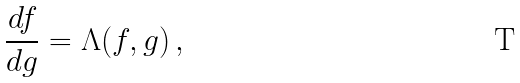<formula> <loc_0><loc_0><loc_500><loc_500>\frac { d f } { d g } = \Lambda ( f , g ) \, ,</formula> 